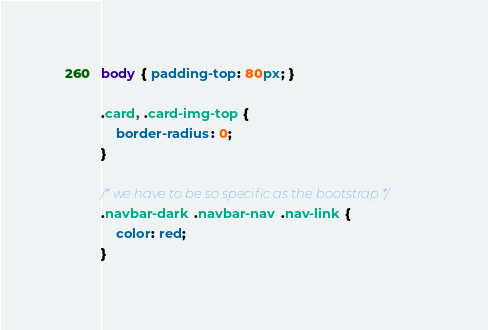<code> <loc_0><loc_0><loc_500><loc_500><_CSS_>body { padding-top: 80px; }

.card, .card-img-top {
	border-radius: 0;
}

/* we have to be so specific as the bootstrap */
.navbar-dark .navbar-nav .nav-link {
	color: red;
}

</code> 